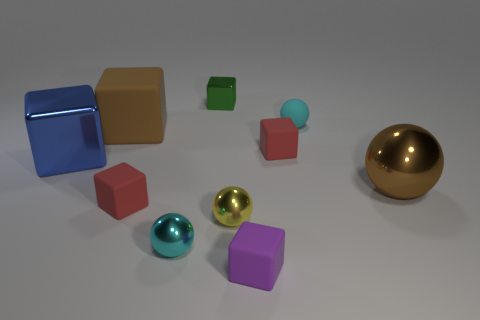Is the number of small metal spheres that are in front of the tiny purple matte cube less than the number of red blocks right of the big metal sphere?
Offer a very short reply. No. Do the purple matte block and the cyan rubber thing have the same size?
Your answer should be compact. Yes. There is a tiny matte object that is both to the right of the tiny purple matte thing and in front of the small cyan rubber thing; what is its shape?
Make the answer very short. Cube. How many green things are made of the same material as the large blue cube?
Offer a very short reply. 1. How many purple matte objects are to the right of the cyan ball that is behind the brown shiny object?
Offer a very short reply. 0. What shape is the brown thing to the right of the small shiny object that is behind the large brown object that is behind the brown ball?
Provide a succinct answer. Sphere. There is a object that is the same color as the small rubber ball; what is its size?
Your answer should be very brief. Small. What number of things are big brown cubes or cyan metallic things?
Make the answer very short. 2. What color is the metallic block that is the same size as the purple matte thing?
Your answer should be compact. Green. Do the large brown matte object and the red matte thing that is left of the tiny purple matte thing have the same shape?
Your response must be concise. Yes. 